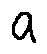<formula> <loc_0><loc_0><loc_500><loc_500>a</formula> 